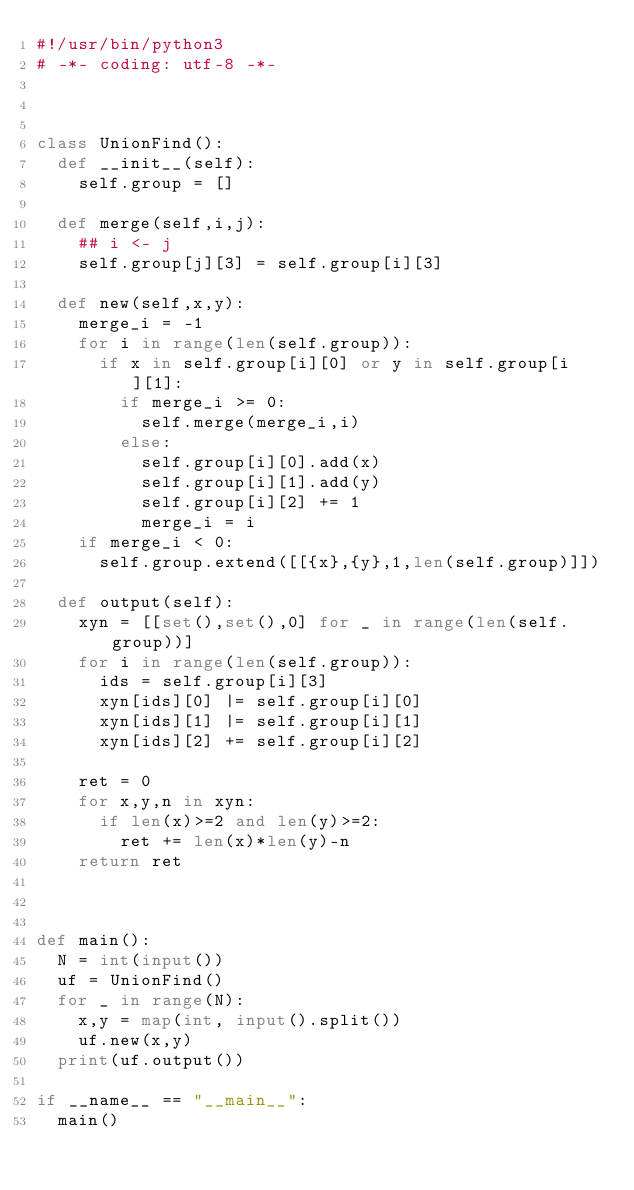<code> <loc_0><loc_0><loc_500><loc_500><_Python_>#!/usr/bin/python3
# -*- coding: utf-8 -*-



class UnionFind():
  def __init__(self):
    self.group = []
  
  def merge(self,i,j):
    ## i <- j
    self.group[j][3] = self.group[i][3]

  def new(self,x,y):
    merge_i = -1
    for i in range(len(self.group)):
      if x in self.group[i][0] or y in self.group[i][1]:
        if merge_i >= 0:
          self.merge(merge_i,i)
        else:
          self.group[i][0].add(x)
          self.group[i][1].add(y)
          self.group[i][2] += 1
          merge_i = i
    if merge_i < 0:
      self.group.extend([[{x},{y},1,len(self.group)]])

  def output(self):
    xyn = [[set(),set(),0] for _ in range(len(self.group))]
    for i in range(len(self.group)):
      ids = self.group[i][3]
      xyn[ids][0] |= self.group[i][0]
      xyn[ids][1] |= self.group[i][1]
      xyn[ids][2] += self.group[i][2]

    ret = 0
    for x,y,n in xyn:
      if len(x)>=2 and len(y)>=2:
        ret += len(x)*len(y)-n
    return ret



def main():
  N = int(input())
  uf = UnionFind()
  for _ in range(N):
    x,y = map(int, input().split())
    uf.new(x,y)
  print(uf.output())

if __name__ == "__main__":
  main()</code> 